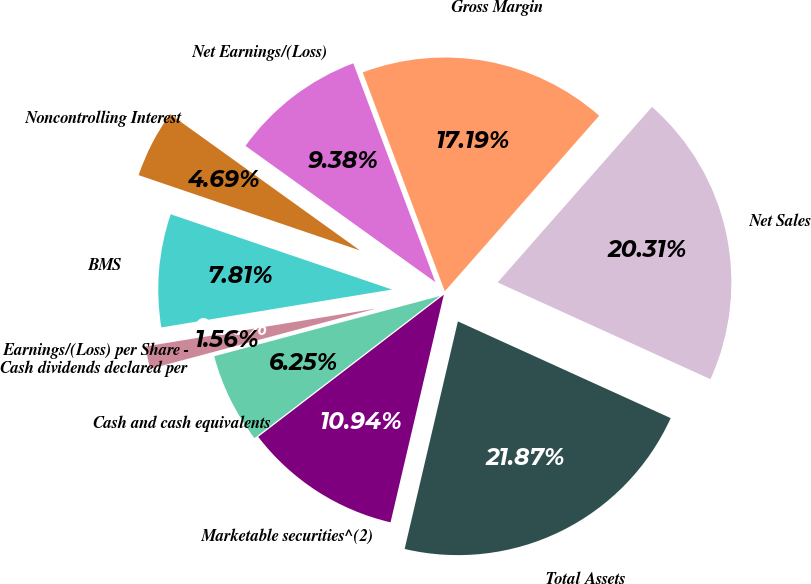Convert chart. <chart><loc_0><loc_0><loc_500><loc_500><pie_chart><fcel>Net Sales<fcel>Gross Margin<fcel>Net Earnings/(Loss)<fcel>Noncontrolling Interest<fcel>BMS<fcel>Earnings/(Loss) per Share -<fcel>Cash dividends declared per<fcel>Cash and cash equivalents<fcel>Marketable securities^(2)<fcel>Total Assets<nl><fcel>20.31%<fcel>17.19%<fcel>9.38%<fcel>4.69%<fcel>7.81%<fcel>0.0%<fcel>1.56%<fcel>6.25%<fcel>10.94%<fcel>21.87%<nl></chart> 